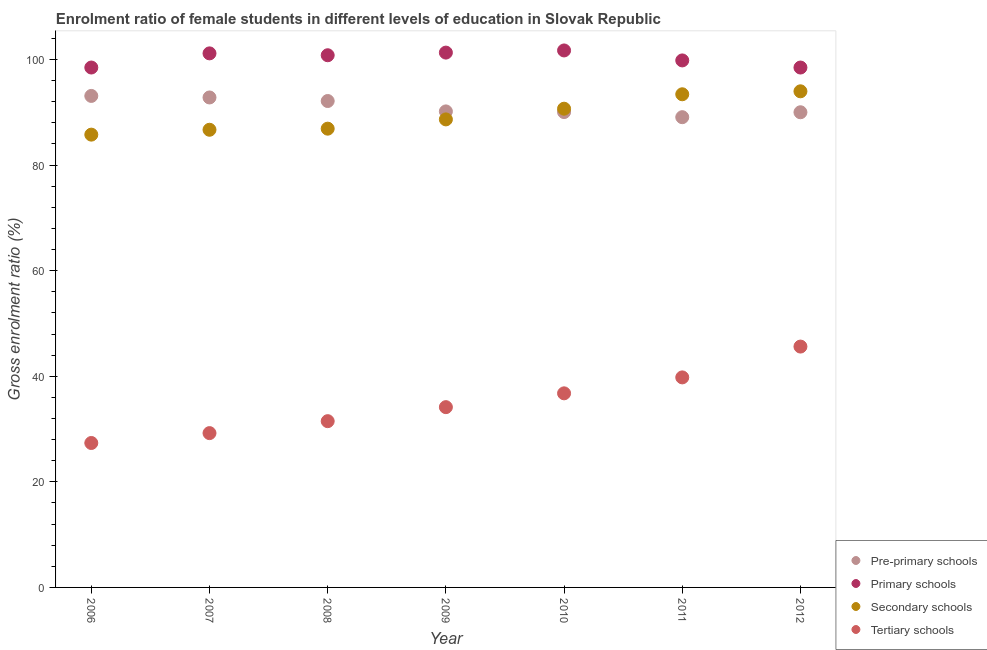How many different coloured dotlines are there?
Your response must be concise. 4. Is the number of dotlines equal to the number of legend labels?
Your answer should be compact. Yes. What is the gross enrolment ratio(male) in secondary schools in 2009?
Your answer should be compact. 88.65. Across all years, what is the maximum gross enrolment ratio(male) in secondary schools?
Ensure brevity in your answer.  93.97. Across all years, what is the minimum gross enrolment ratio(male) in tertiary schools?
Offer a terse response. 27.36. In which year was the gross enrolment ratio(male) in pre-primary schools maximum?
Make the answer very short. 2006. What is the total gross enrolment ratio(male) in pre-primary schools in the graph?
Provide a short and direct response. 637.28. What is the difference between the gross enrolment ratio(male) in pre-primary schools in 2007 and that in 2010?
Keep it short and to the point. 2.76. What is the difference between the gross enrolment ratio(male) in primary schools in 2006 and the gross enrolment ratio(male) in secondary schools in 2009?
Provide a succinct answer. 9.82. What is the average gross enrolment ratio(male) in tertiary schools per year?
Provide a succinct answer. 34.91. In the year 2009, what is the difference between the gross enrolment ratio(male) in secondary schools and gross enrolment ratio(male) in pre-primary schools?
Provide a succinct answer. -1.51. In how many years, is the gross enrolment ratio(male) in secondary schools greater than 4 %?
Ensure brevity in your answer.  7. What is the ratio of the gross enrolment ratio(male) in pre-primary schools in 2006 to that in 2008?
Provide a succinct answer. 1.01. What is the difference between the highest and the second highest gross enrolment ratio(male) in secondary schools?
Your answer should be very brief. 0.56. What is the difference between the highest and the lowest gross enrolment ratio(male) in pre-primary schools?
Keep it short and to the point. 4.03. In how many years, is the gross enrolment ratio(male) in primary schools greater than the average gross enrolment ratio(male) in primary schools taken over all years?
Provide a short and direct response. 4. Is the sum of the gross enrolment ratio(male) in secondary schools in 2006 and 2009 greater than the maximum gross enrolment ratio(male) in primary schools across all years?
Provide a succinct answer. Yes. Is it the case that in every year, the sum of the gross enrolment ratio(male) in tertiary schools and gross enrolment ratio(male) in pre-primary schools is greater than the sum of gross enrolment ratio(male) in secondary schools and gross enrolment ratio(male) in primary schools?
Ensure brevity in your answer.  No. Is it the case that in every year, the sum of the gross enrolment ratio(male) in pre-primary schools and gross enrolment ratio(male) in primary schools is greater than the gross enrolment ratio(male) in secondary schools?
Offer a terse response. Yes. Is the gross enrolment ratio(male) in pre-primary schools strictly greater than the gross enrolment ratio(male) in primary schools over the years?
Make the answer very short. No. Is the gross enrolment ratio(male) in tertiary schools strictly less than the gross enrolment ratio(male) in secondary schools over the years?
Make the answer very short. Yes. How many dotlines are there?
Keep it short and to the point. 4. How many years are there in the graph?
Offer a terse response. 7. What is the difference between two consecutive major ticks on the Y-axis?
Keep it short and to the point. 20. Are the values on the major ticks of Y-axis written in scientific E-notation?
Your answer should be compact. No. What is the title of the graph?
Keep it short and to the point. Enrolment ratio of female students in different levels of education in Slovak Republic. Does "Other Minerals" appear as one of the legend labels in the graph?
Your answer should be very brief. No. What is the label or title of the X-axis?
Your response must be concise. Year. What is the label or title of the Y-axis?
Offer a very short reply. Gross enrolment ratio (%). What is the Gross enrolment ratio (%) of Pre-primary schools in 2006?
Your answer should be very brief. 93.09. What is the Gross enrolment ratio (%) in Primary schools in 2006?
Give a very brief answer. 98.47. What is the Gross enrolment ratio (%) of Secondary schools in 2006?
Give a very brief answer. 85.76. What is the Gross enrolment ratio (%) in Tertiary schools in 2006?
Provide a succinct answer. 27.36. What is the Gross enrolment ratio (%) of Pre-primary schools in 2007?
Offer a very short reply. 92.8. What is the Gross enrolment ratio (%) in Primary schools in 2007?
Ensure brevity in your answer.  101.15. What is the Gross enrolment ratio (%) of Secondary schools in 2007?
Offer a very short reply. 86.68. What is the Gross enrolment ratio (%) of Tertiary schools in 2007?
Make the answer very short. 29.23. What is the Gross enrolment ratio (%) of Pre-primary schools in 2008?
Your response must be concise. 92.13. What is the Gross enrolment ratio (%) of Primary schools in 2008?
Give a very brief answer. 100.8. What is the Gross enrolment ratio (%) in Secondary schools in 2008?
Give a very brief answer. 86.89. What is the Gross enrolment ratio (%) in Tertiary schools in 2008?
Offer a very short reply. 31.49. What is the Gross enrolment ratio (%) of Pre-primary schools in 2009?
Provide a succinct answer. 90.16. What is the Gross enrolment ratio (%) of Primary schools in 2009?
Keep it short and to the point. 101.3. What is the Gross enrolment ratio (%) in Secondary schools in 2009?
Your response must be concise. 88.65. What is the Gross enrolment ratio (%) in Tertiary schools in 2009?
Ensure brevity in your answer.  34.15. What is the Gross enrolment ratio (%) of Pre-primary schools in 2010?
Offer a terse response. 90.04. What is the Gross enrolment ratio (%) in Primary schools in 2010?
Your response must be concise. 101.71. What is the Gross enrolment ratio (%) of Secondary schools in 2010?
Offer a very short reply. 90.67. What is the Gross enrolment ratio (%) of Tertiary schools in 2010?
Your answer should be very brief. 36.76. What is the Gross enrolment ratio (%) of Pre-primary schools in 2011?
Your answer should be very brief. 89.07. What is the Gross enrolment ratio (%) in Primary schools in 2011?
Your response must be concise. 99.82. What is the Gross enrolment ratio (%) in Secondary schools in 2011?
Ensure brevity in your answer.  93.41. What is the Gross enrolment ratio (%) of Tertiary schools in 2011?
Provide a succinct answer. 39.78. What is the Gross enrolment ratio (%) in Pre-primary schools in 2012?
Your answer should be very brief. 90. What is the Gross enrolment ratio (%) of Primary schools in 2012?
Offer a terse response. 98.47. What is the Gross enrolment ratio (%) of Secondary schools in 2012?
Offer a terse response. 93.97. What is the Gross enrolment ratio (%) in Tertiary schools in 2012?
Offer a very short reply. 45.62. Across all years, what is the maximum Gross enrolment ratio (%) in Pre-primary schools?
Your answer should be very brief. 93.09. Across all years, what is the maximum Gross enrolment ratio (%) in Primary schools?
Offer a terse response. 101.71. Across all years, what is the maximum Gross enrolment ratio (%) of Secondary schools?
Provide a short and direct response. 93.97. Across all years, what is the maximum Gross enrolment ratio (%) of Tertiary schools?
Provide a succinct answer. 45.62. Across all years, what is the minimum Gross enrolment ratio (%) of Pre-primary schools?
Offer a terse response. 89.07. Across all years, what is the minimum Gross enrolment ratio (%) in Primary schools?
Give a very brief answer. 98.47. Across all years, what is the minimum Gross enrolment ratio (%) in Secondary schools?
Your response must be concise. 85.76. Across all years, what is the minimum Gross enrolment ratio (%) in Tertiary schools?
Your answer should be compact. 27.36. What is the total Gross enrolment ratio (%) in Pre-primary schools in the graph?
Provide a succinct answer. 637.28. What is the total Gross enrolment ratio (%) in Primary schools in the graph?
Give a very brief answer. 701.71. What is the total Gross enrolment ratio (%) of Secondary schools in the graph?
Keep it short and to the point. 626.03. What is the total Gross enrolment ratio (%) of Tertiary schools in the graph?
Your response must be concise. 244.38. What is the difference between the Gross enrolment ratio (%) of Pre-primary schools in 2006 and that in 2007?
Keep it short and to the point. 0.29. What is the difference between the Gross enrolment ratio (%) in Primary schools in 2006 and that in 2007?
Keep it short and to the point. -2.68. What is the difference between the Gross enrolment ratio (%) of Secondary schools in 2006 and that in 2007?
Your answer should be very brief. -0.92. What is the difference between the Gross enrolment ratio (%) of Tertiary schools in 2006 and that in 2007?
Offer a very short reply. -1.87. What is the difference between the Gross enrolment ratio (%) of Pre-primary schools in 2006 and that in 2008?
Give a very brief answer. 0.96. What is the difference between the Gross enrolment ratio (%) in Primary schools in 2006 and that in 2008?
Your response must be concise. -2.33. What is the difference between the Gross enrolment ratio (%) of Secondary schools in 2006 and that in 2008?
Your answer should be very brief. -1.13. What is the difference between the Gross enrolment ratio (%) in Tertiary schools in 2006 and that in 2008?
Your answer should be very brief. -4.14. What is the difference between the Gross enrolment ratio (%) of Pre-primary schools in 2006 and that in 2009?
Offer a terse response. 2.93. What is the difference between the Gross enrolment ratio (%) of Primary schools in 2006 and that in 2009?
Make the answer very short. -2.83. What is the difference between the Gross enrolment ratio (%) in Secondary schools in 2006 and that in 2009?
Offer a terse response. -2.89. What is the difference between the Gross enrolment ratio (%) in Tertiary schools in 2006 and that in 2009?
Offer a very short reply. -6.79. What is the difference between the Gross enrolment ratio (%) of Pre-primary schools in 2006 and that in 2010?
Provide a short and direct response. 3.06. What is the difference between the Gross enrolment ratio (%) of Primary schools in 2006 and that in 2010?
Your answer should be compact. -3.23. What is the difference between the Gross enrolment ratio (%) of Secondary schools in 2006 and that in 2010?
Keep it short and to the point. -4.91. What is the difference between the Gross enrolment ratio (%) of Tertiary schools in 2006 and that in 2010?
Offer a very short reply. -9.41. What is the difference between the Gross enrolment ratio (%) of Pre-primary schools in 2006 and that in 2011?
Provide a short and direct response. 4.03. What is the difference between the Gross enrolment ratio (%) of Primary schools in 2006 and that in 2011?
Give a very brief answer. -1.35. What is the difference between the Gross enrolment ratio (%) of Secondary schools in 2006 and that in 2011?
Keep it short and to the point. -7.64. What is the difference between the Gross enrolment ratio (%) in Tertiary schools in 2006 and that in 2011?
Offer a very short reply. -12.43. What is the difference between the Gross enrolment ratio (%) of Pre-primary schools in 2006 and that in 2012?
Offer a terse response. 3.09. What is the difference between the Gross enrolment ratio (%) in Primary schools in 2006 and that in 2012?
Provide a short and direct response. 0. What is the difference between the Gross enrolment ratio (%) in Secondary schools in 2006 and that in 2012?
Offer a very short reply. -8.21. What is the difference between the Gross enrolment ratio (%) of Tertiary schools in 2006 and that in 2012?
Ensure brevity in your answer.  -18.26. What is the difference between the Gross enrolment ratio (%) of Pre-primary schools in 2007 and that in 2008?
Make the answer very short. 0.67. What is the difference between the Gross enrolment ratio (%) in Primary schools in 2007 and that in 2008?
Make the answer very short. 0.36. What is the difference between the Gross enrolment ratio (%) of Secondary schools in 2007 and that in 2008?
Ensure brevity in your answer.  -0.21. What is the difference between the Gross enrolment ratio (%) of Tertiary schools in 2007 and that in 2008?
Offer a terse response. -2.26. What is the difference between the Gross enrolment ratio (%) of Pre-primary schools in 2007 and that in 2009?
Keep it short and to the point. 2.64. What is the difference between the Gross enrolment ratio (%) in Primary schools in 2007 and that in 2009?
Offer a terse response. -0.15. What is the difference between the Gross enrolment ratio (%) in Secondary schools in 2007 and that in 2009?
Make the answer very short. -1.96. What is the difference between the Gross enrolment ratio (%) in Tertiary schools in 2007 and that in 2009?
Keep it short and to the point. -4.92. What is the difference between the Gross enrolment ratio (%) of Pre-primary schools in 2007 and that in 2010?
Give a very brief answer. 2.76. What is the difference between the Gross enrolment ratio (%) of Primary schools in 2007 and that in 2010?
Give a very brief answer. -0.55. What is the difference between the Gross enrolment ratio (%) in Secondary schools in 2007 and that in 2010?
Make the answer very short. -3.99. What is the difference between the Gross enrolment ratio (%) in Tertiary schools in 2007 and that in 2010?
Ensure brevity in your answer.  -7.53. What is the difference between the Gross enrolment ratio (%) of Pre-primary schools in 2007 and that in 2011?
Keep it short and to the point. 3.74. What is the difference between the Gross enrolment ratio (%) of Primary schools in 2007 and that in 2011?
Offer a very short reply. 1.34. What is the difference between the Gross enrolment ratio (%) in Secondary schools in 2007 and that in 2011?
Keep it short and to the point. -6.72. What is the difference between the Gross enrolment ratio (%) of Tertiary schools in 2007 and that in 2011?
Give a very brief answer. -10.55. What is the difference between the Gross enrolment ratio (%) in Pre-primary schools in 2007 and that in 2012?
Ensure brevity in your answer.  2.8. What is the difference between the Gross enrolment ratio (%) of Primary schools in 2007 and that in 2012?
Offer a very short reply. 2.68. What is the difference between the Gross enrolment ratio (%) of Secondary schools in 2007 and that in 2012?
Ensure brevity in your answer.  -7.28. What is the difference between the Gross enrolment ratio (%) of Tertiary schools in 2007 and that in 2012?
Keep it short and to the point. -16.39. What is the difference between the Gross enrolment ratio (%) in Pre-primary schools in 2008 and that in 2009?
Give a very brief answer. 1.97. What is the difference between the Gross enrolment ratio (%) in Primary schools in 2008 and that in 2009?
Your answer should be compact. -0.5. What is the difference between the Gross enrolment ratio (%) of Secondary schools in 2008 and that in 2009?
Offer a terse response. -1.76. What is the difference between the Gross enrolment ratio (%) in Tertiary schools in 2008 and that in 2009?
Provide a short and direct response. -2.65. What is the difference between the Gross enrolment ratio (%) in Pre-primary schools in 2008 and that in 2010?
Provide a succinct answer. 2.09. What is the difference between the Gross enrolment ratio (%) in Primary schools in 2008 and that in 2010?
Give a very brief answer. -0.91. What is the difference between the Gross enrolment ratio (%) of Secondary schools in 2008 and that in 2010?
Provide a short and direct response. -3.78. What is the difference between the Gross enrolment ratio (%) in Tertiary schools in 2008 and that in 2010?
Your answer should be very brief. -5.27. What is the difference between the Gross enrolment ratio (%) in Pre-primary schools in 2008 and that in 2011?
Keep it short and to the point. 3.06. What is the difference between the Gross enrolment ratio (%) of Primary schools in 2008 and that in 2011?
Your answer should be very brief. 0.98. What is the difference between the Gross enrolment ratio (%) of Secondary schools in 2008 and that in 2011?
Keep it short and to the point. -6.51. What is the difference between the Gross enrolment ratio (%) in Tertiary schools in 2008 and that in 2011?
Offer a very short reply. -8.29. What is the difference between the Gross enrolment ratio (%) in Pre-primary schools in 2008 and that in 2012?
Your answer should be very brief. 2.13. What is the difference between the Gross enrolment ratio (%) of Primary schools in 2008 and that in 2012?
Make the answer very short. 2.33. What is the difference between the Gross enrolment ratio (%) in Secondary schools in 2008 and that in 2012?
Ensure brevity in your answer.  -7.08. What is the difference between the Gross enrolment ratio (%) in Tertiary schools in 2008 and that in 2012?
Your answer should be compact. -14.13. What is the difference between the Gross enrolment ratio (%) of Pre-primary schools in 2009 and that in 2010?
Give a very brief answer. 0.12. What is the difference between the Gross enrolment ratio (%) in Primary schools in 2009 and that in 2010?
Offer a very short reply. -0.41. What is the difference between the Gross enrolment ratio (%) of Secondary schools in 2009 and that in 2010?
Your answer should be very brief. -2.03. What is the difference between the Gross enrolment ratio (%) in Tertiary schools in 2009 and that in 2010?
Your answer should be compact. -2.62. What is the difference between the Gross enrolment ratio (%) in Pre-primary schools in 2009 and that in 2011?
Give a very brief answer. 1.09. What is the difference between the Gross enrolment ratio (%) in Primary schools in 2009 and that in 2011?
Offer a very short reply. 1.48. What is the difference between the Gross enrolment ratio (%) of Secondary schools in 2009 and that in 2011?
Offer a terse response. -4.76. What is the difference between the Gross enrolment ratio (%) of Tertiary schools in 2009 and that in 2011?
Provide a succinct answer. -5.64. What is the difference between the Gross enrolment ratio (%) of Pre-primary schools in 2009 and that in 2012?
Ensure brevity in your answer.  0.16. What is the difference between the Gross enrolment ratio (%) in Primary schools in 2009 and that in 2012?
Your answer should be compact. 2.83. What is the difference between the Gross enrolment ratio (%) in Secondary schools in 2009 and that in 2012?
Make the answer very short. -5.32. What is the difference between the Gross enrolment ratio (%) in Tertiary schools in 2009 and that in 2012?
Your response must be concise. -11.47. What is the difference between the Gross enrolment ratio (%) of Pre-primary schools in 2010 and that in 2011?
Ensure brevity in your answer.  0.97. What is the difference between the Gross enrolment ratio (%) of Primary schools in 2010 and that in 2011?
Your response must be concise. 1.89. What is the difference between the Gross enrolment ratio (%) in Secondary schools in 2010 and that in 2011?
Keep it short and to the point. -2.73. What is the difference between the Gross enrolment ratio (%) in Tertiary schools in 2010 and that in 2011?
Give a very brief answer. -3.02. What is the difference between the Gross enrolment ratio (%) in Pre-primary schools in 2010 and that in 2012?
Give a very brief answer. 0.04. What is the difference between the Gross enrolment ratio (%) of Primary schools in 2010 and that in 2012?
Your answer should be very brief. 3.24. What is the difference between the Gross enrolment ratio (%) in Secondary schools in 2010 and that in 2012?
Make the answer very short. -3.29. What is the difference between the Gross enrolment ratio (%) of Tertiary schools in 2010 and that in 2012?
Your answer should be very brief. -8.86. What is the difference between the Gross enrolment ratio (%) of Pre-primary schools in 2011 and that in 2012?
Provide a short and direct response. -0.93. What is the difference between the Gross enrolment ratio (%) of Primary schools in 2011 and that in 2012?
Your answer should be compact. 1.35. What is the difference between the Gross enrolment ratio (%) of Secondary schools in 2011 and that in 2012?
Your answer should be very brief. -0.56. What is the difference between the Gross enrolment ratio (%) in Tertiary schools in 2011 and that in 2012?
Your answer should be compact. -5.84. What is the difference between the Gross enrolment ratio (%) in Pre-primary schools in 2006 and the Gross enrolment ratio (%) in Primary schools in 2007?
Give a very brief answer. -8.06. What is the difference between the Gross enrolment ratio (%) of Pre-primary schools in 2006 and the Gross enrolment ratio (%) of Secondary schools in 2007?
Ensure brevity in your answer.  6.41. What is the difference between the Gross enrolment ratio (%) in Pre-primary schools in 2006 and the Gross enrolment ratio (%) in Tertiary schools in 2007?
Provide a succinct answer. 63.86. What is the difference between the Gross enrolment ratio (%) in Primary schools in 2006 and the Gross enrolment ratio (%) in Secondary schools in 2007?
Provide a succinct answer. 11.79. What is the difference between the Gross enrolment ratio (%) of Primary schools in 2006 and the Gross enrolment ratio (%) of Tertiary schools in 2007?
Your response must be concise. 69.24. What is the difference between the Gross enrolment ratio (%) in Secondary schools in 2006 and the Gross enrolment ratio (%) in Tertiary schools in 2007?
Provide a succinct answer. 56.53. What is the difference between the Gross enrolment ratio (%) of Pre-primary schools in 2006 and the Gross enrolment ratio (%) of Primary schools in 2008?
Your answer should be compact. -7.71. What is the difference between the Gross enrolment ratio (%) of Pre-primary schools in 2006 and the Gross enrolment ratio (%) of Secondary schools in 2008?
Offer a terse response. 6.2. What is the difference between the Gross enrolment ratio (%) in Pre-primary schools in 2006 and the Gross enrolment ratio (%) in Tertiary schools in 2008?
Make the answer very short. 61.6. What is the difference between the Gross enrolment ratio (%) in Primary schools in 2006 and the Gross enrolment ratio (%) in Secondary schools in 2008?
Your answer should be very brief. 11.58. What is the difference between the Gross enrolment ratio (%) of Primary schools in 2006 and the Gross enrolment ratio (%) of Tertiary schools in 2008?
Provide a short and direct response. 66.98. What is the difference between the Gross enrolment ratio (%) of Secondary schools in 2006 and the Gross enrolment ratio (%) of Tertiary schools in 2008?
Your answer should be compact. 54.27. What is the difference between the Gross enrolment ratio (%) in Pre-primary schools in 2006 and the Gross enrolment ratio (%) in Primary schools in 2009?
Make the answer very short. -8.21. What is the difference between the Gross enrolment ratio (%) in Pre-primary schools in 2006 and the Gross enrolment ratio (%) in Secondary schools in 2009?
Offer a very short reply. 4.44. What is the difference between the Gross enrolment ratio (%) of Pre-primary schools in 2006 and the Gross enrolment ratio (%) of Tertiary schools in 2009?
Your response must be concise. 58.95. What is the difference between the Gross enrolment ratio (%) in Primary schools in 2006 and the Gross enrolment ratio (%) in Secondary schools in 2009?
Ensure brevity in your answer.  9.82. What is the difference between the Gross enrolment ratio (%) in Primary schools in 2006 and the Gross enrolment ratio (%) in Tertiary schools in 2009?
Your response must be concise. 64.33. What is the difference between the Gross enrolment ratio (%) in Secondary schools in 2006 and the Gross enrolment ratio (%) in Tertiary schools in 2009?
Your answer should be compact. 51.62. What is the difference between the Gross enrolment ratio (%) of Pre-primary schools in 2006 and the Gross enrolment ratio (%) of Primary schools in 2010?
Provide a short and direct response. -8.61. What is the difference between the Gross enrolment ratio (%) of Pre-primary schools in 2006 and the Gross enrolment ratio (%) of Secondary schools in 2010?
Your answer should be very brief. 2.42. What is the difference between the Gross enrolment ratio (%) of Pre-primary schools in 2006 and the Gross enrolment ratio (%) of Tertiary schools in 2010?
Provide a short and direct response. 56.33. What is the difference between the Gross enrolment ratio (%) in Primary schools in 2006 and the Gross enrolment ratio (%) in Secondary schools in 2010?
Offer a terse response. 7.8. What is the difference between the Gross enrolment ratio (%) in Primary schools in 2006 and the Gross enrolment ratio (%) in Tertiary schools in 2010?
Offer a very short reply. 61.71. What is the difference between the Gross enrolment ratio (%) in Secondary schools in 2006 and the Gross enrolment ratio (%) in Tertiary schools in 2010?
Your answer should be very brief. 49. What is the difference between the Gross enrolment ratio (%) in Pre-primary schools in 2006 and the Gross enrolment ratio (%) in Primary schools in 2011?
Your response must be concise. -6.73. What is the difference between the Gross enrolment ratio (%) in Pre-primary schools in 2006 and the Gross enrolment ratio (%) in Secondary schools in 2011?
Make the answer very short. -0.31. What is the difference between the Gross enrolment ratio (%) of Pre-primary schools in 2006 and the Gross enrolment ratio (%) of Tertiary schools in 2011?
Ensure brevity in your answer.  53.31. What is the difference between the Gross enrolment ratio (%) of Primary schools in 2006 and the Gross enrolment ratio (%) of Secondary schools in 2011?
Provide a succinct answer. 5.07. What is the difference between the Gross enrolment ratio (%) in Primary schools in 2006 and the Gross enrolment ratio (%) in Tertiary schools in 2011?
Ensure brevity in your answer.  58.69. What is the difference between the Gross enrolment ratio (%) in Secondary schools in 2006 and the Gross enrolment ratio (%) in Tertiary schools in 2011?
Ensure brevity in your answer.  45.98. What is the difference between the Gross enrolment ratio (%) in Pre-primary schools in 2006 and the Gross enrolment ratio (%) in Primary schools in 2012?
Keep it short and to the point. -5.38. What is the difference between the Gross enrolment ratio (%) of Pre-primary schools in 2006 and the Gross enrolment ratio (%) of Secondary schools in 2012?
Provide a short and direct response. -0.88. What is the difference between the Gross enrolment ratio (%) in Pre-primary schools in 2006 and the Gross enrolment ratio (%) in Tertiary schools in 2012?
Make the answer very short. 47.47. What is the difference between the Gross enrolment ratio (%) in Primary schools in 2006 and the Gross enrolment ratio (%) in Secondary schools in 2012?
Ensure brevity in your answer.  4.5. What is the difference between the Gross enrolment ratio (%) in Primary schools in 2006 and the Gross enrolment ratio (%) in Tertiary schools in 2012?
Give a very brief answer. 52.85. What is the difference between the Gross enrolment ratio (%) in Secondary schools in 2006 and the Gross enrolment ratio (%) in Tertiary schools in 2012?
Provide a short and direct response. 40.14. What is the difference between the Gross enrolment ratio (%) of Pre-primary schools in 2007 and the Gross enrolment ratio (%) of Primary schools in 2008?
Offer a very short reply. -8. What is the difference between the Gross enrolment ratio (%) in Pre-primary schools in 2007 and the Gross enrolment ratio (%) in Secondary schools in 2008?
Give a very brief answer. 5.91. What is the difference between the Gross enrolment ratio (%) in Pre-primary schools in 2007 and the Gross enrolment ratio (%) in Tertiary schools in 2008?
Make the answer very short. 61.31. What is the difference between the Gross enrolment ratio (%) in Primary schools in 2007 and the Gross enrolment ratio (%) in Secondary schools in 2008?
Ensure brevity in your answer.  14.26. What is the difference between the Gross enrolment ratio (%) in Primary schools in 2007 and the Gross enrolment ratio (%) in Tertiary schools in 2008?
Keep it short and to the point. 69.66. What is the difference between the Gross enrolment ratio (%) in Secondary schools in 2007 and the Gross enrolment ratio (%) in Tertiary schools in 2008?
Your response must be concise. 55.19. What is the difference between the Gross enrolment ratio (%) of Pre-primary schools in 2007 and the Gross enrolment ratio (%) of Primary schools in 2009?
Give a very brief answer. -8.5. What is the difference between the Gross enrolment ratio (%) of Pre-primary schools in 2007 and the Gross enrolment ratio (%) of Secondary schools in 2009?
Make the answer very short. 4.15. What is the difference between the Gross enrolment ratio (%) of Pre-primary schools in 2007 and the Gross enrolment ratio (%) of Tertiary schools in 2009?
Provide a short and direct response. 58.66. What is the difference between the Gross enrolment ratio (%) in Primary schools in 2007 and the Gross enrolment ratio (%) in Secondary schools in 2009?
Provide a succinct answer. 12.51. What is the difference between the Gross enrolment ratio (%) in Primary schools in 2007 and the Gross enrolment ratio (%) in Tertiary schools in 2009?
Your answer should be very brief. 67.01. What is the difference between the Gross enrolment ratio (%) in Secondary schools in 2007 and the Gross enrolment ratio (%) in Tertiary schools in 2009?
Give a very brief answer. 52.54. What is the difference between the Gross enrolment ratio (%) in Pre-primary schools in 2007 and the Gross enrolment ratio (%) in Primary schools in 2010?
Provide a short and direct response. -8.9. What is the difference between the Gross enrolment ratio (%) of Pre-primary schools in 2007 and the Gross enrolment ratio (%) of Secondary schools in 2010?
Make the answer very short. 2.13. What is the difference between the Gross enrolment ratio (%) of Pre-primary schools in 2007 and the Gross enrolment ratio (%) of Tertiary schools in 2010?
Ensure brevity in your answer.  56.04. What is the difference between the Gross enrolment ratio (%) of Primary schools in 2007 and the Gross enrolment ratio (%) of Secondary schools in 2010?
Offer a terse response. 10.48. What is the difference between the Gross enrolment ratio (%) in Primary schools in 2007 and the Gross enrolment ratio (%) in Tertiary schools in 2010?
Your answer should be compact. 64.39. What is the difference between the Gross enrolment ratio (%) in Secondary schools in 2007 and the Gross enrolment ratio (%) in Tertiary schools in 2010?
Make the answer very short. 49.92. What is the difference between the Gross enrolment ratio (%) of Pre-primary schools in 2007 and the Gross enrolment ratio (%) of Primary schools in 2011?
Your answer should be very brief. -7.02. What is the difference between the Gross enrolment ratio (%) of Pre-primary schools in 2007 and the Gross enrolment ratio (%) of Secondary schools in 2011?
Your answer should be compact. -0.6. What is the difference between the Gross enrolment ratio (%) of Pre-primary schools in 2007 and the Gross enrolment ratio (%) of Tertiary schools in 2011?
Make the answer very short. 53.02. What is the difference between the Gross enrolment ratio (%) in Primary schools in 2007 and the Gross enrolment ratio (%) in Secondary schools in 2011?
Your answer should be compact. 7.75. What is the difference between the Gross enrolment ratio (%) in Primary schools in 2007 and the Gross enrolment ratio (%) in Tertiary schools in 2011?
Provide a short and direct response. 61.37. What is the difference between the Gross enrolment ratio (%) of Secondary schools in 2007 and the Gross enrolment ratio (%) of Tertiary schools in 2011?
Make the answer very short. 46.9. What is the difference between the Gross enrolment ratio (%) of Pre-primary schools in 2007 and the Gross enrolment ratio (%) of Primary schools in 2012?
Your response must be concise. -5.67. What is the difference between the Gross enrolment ratio (%) in Pre-primary schools in 2007 and the Gross enrolment ratio (%) in Secondary schools in 2012?
Your answer should be compact. -1.17. What is the difference between the Gross enrolment ratio (%) of Pre-primary schools in 2007 and the Gross enrolment ratio (%) of Tertiary schools in 2012?
Provide a short and direct response. 47.18. What is the difference between the Gross enrolment ratio (%) in Primary schools in 2007 and the Gross enrolment ratio (%) in Secondary schools in 2012?
Provide a succinct answer. 7.19. What is the difference between the Gross enrolment ratio (%) in Primary schools in 2007 and the Gross enrolment ratio (%) in Tertiary schools in 2012?
Your response must be concise. 55.53. What is the difference between the Gross enrolment ratio (%) in Secondary schools in 2007 and the Gross enrolment ratio (%) in Tertiary schools in 2012?
Offer a terse response. 41.06. What is the difference between the Gross enrolment ratio (%) of Pre-primary schools in 2008 and the Gross enrolment ratio (%) of Primary schools in 2009?
Make the answer very short. -9.17. What is the difference between the Gross enrolment ratio (%) of Pre-primary schools in 2008 and the Gross enrolment ratio (%) of Secondary schools in 2009?
Your answer should be compact. 3.48. What is the difference between the Gross enrolment ratio (%) in Pre-primary schools in 2008 and the Gross enrolment ratio (%) in Tertiary schools in 2009?
Offer a terse response. 57.98. What is the difference between the Gross enrolment ratio (%) of Primary schools in 2008 and the Gross enrolment ratio (%) of Secondary schools in 2009?
Provide a short and direct response. 12.15. What is the difference between the Gross enrolment ratio (%) of Primary schools in 2008 and the Gross enrolment ratio (%) of Tertiary schools in 2009?
Give a very brief answer. 66.65. What is the difference between the Gross enrolment ratio (%) of Secondary schools in 2008 and the Gross enrolment ratio (%) of Tertiary schools in 2009?
Your answer should be compact. 52.74. What is the difference between the Gross enrolment ratio (%) of Pre-primary schools in 2008 and the Gross enrolment ratio (%) of Primary schools in 2010?
Your answer should be compact. -9.58. What is the difference between the Gross enrolment ratio (%) of Pre-primary schools in 2008 and the Gross enrolment ratio (%) of Secondary schools in 2010?
Provide a short and direct response. 1.45. What is the difference between the Gross enrolment ratio (%) in Pre-primary schools in 2008 and the Gross enrolment ratio (%) in Tertiary schools in 2010?
Ensure brevity in your answer.  55.37. What is the difference between the Gross enrolment ratio (%) in Primary schools in 2008 and the Gross enrolment ratio (%) in Secondary schools in 2010?
Make the answer very short. 10.12. What is the difference between the Gross enrolment ratio (%) in Primary schools in 2008 and the Gross enrolment ratio (%) in Tertiary schools in 2010?
Your answer should be compact. 64.04. What is the difference between the Gross enrolment ratio (%) in Secondary schools in 2008 and the Gross enrolment ratio (%) in Tertiary schools in 2010?
Keep it short and to the point. 50.13. What is the difference between the Gross enrolment ratio (%) of Pre-primary schools in 2008 and the Gross enrolment ratio (%) of Primary schools in 2011?
Provide a succinct answer. -7.69. What is the difference between the Gross enrolment ratio (%) in Pre-primary schools in 2008 and the Gross enrolment ratio (%) in Secondary schools in 2011?
Keep it short and to the point. -1.28. What is the difference between the Gross enrolment ratio (%) in Pre-primary schools in 2008 and the Gross enrolment ratio (%) in Tertiary schools in 2011?
Your response must be concise. 52.35. What is the difference between the Gross enrolment ratio (%) in Primary schools in 2008 and the Gross enrolment ratio (%) in Secondary schools in 2011?
Keep it short and to the point. 7.39. What is the difference between the Gross enrolment ratio (%) in Primary schools in 2008 and the Gross enrolment ratio (%) in Tertiary schools in 2011?
Your answer should be very brief. 61.02. What is the difference between the Gross enrolment ratio (%) in Secondary schools in 2008 and the Gross enrolment ratio (%) in Tertiary schools in 2011?
Your answer should be compact. 47.11. What is the difference between the Gross enrolment ratio (%) of Pre-primary schools in 2008 and the Gross enrolment ratio (%) of Primary schools in 2012?
Make the answer very short. -6.34. What is the difference between the Gross enrolment ratio (%) in Pre-primary schools in 2008 and the Gross enrolment ratio (%) in Secondary schools in 2012?
Ensure brevity in your answer.  -1.84. What is the difference between the Gross enrolment ratio (%) of Pre-primary schools in 2008 and the Gross enrolment ratio (%) of Tertiary schools in 2012?
Offer a very short reply. 46.51. What is the difference between the Gross enrolment ratio (%) of Primary schools in 2008 and the Gross enrolment ratio (%) of Secondary schools in 2012?
Give a very brief answer. 6.83. What is the difference between the Gross enrolment ratio (%) in Primary schools in 2008 and the Gross enrolment ratio (%) in Tertiary schools in 2012?
Provide a short and direct response. 55.18. What is the difference between the Gross enrolment ratio (%) in Secondary schools in 2008 and the Gross enrolment ratio (%) in Tertiary schools in 2012?
Ensure brevity in your answer.  41.27. What is the difference between the Gross enrolment ratio (%) in Pre-primary schools in 2009 and the Gross enrolment ratio (%) in Primary schools in 2010?
Provide a short and direct response. -11.54. What is the difference between the Gross enrolment ratio (%) in Pre-primary schools in 2009 and the Gross enrolment ratio (%) in Secondary schools in 2010?
Make the answer very short. -0.51. What is the difference between the Gross enrolment ratio (%) of Pre-primary schools in 2009 and the Gross enrolment ratio (%) of Tertiary schools in 2010?
Your response must be concise. 53.4. What is the difference between the Gross enrolment ratio (%) of Primary schools in 2009 and the Gross enrolment ratio (%) of Secondary schools in 2010?
Give a very brief answer. 10.62. What is the difference between the Gross enrolment ratio (%) of Primary schools in 2009 and the Gross enrolment ratio (%) of Tertiary schools in 2010?
Your answer should be compact. 64.54. What is the difference between the Gross enrolment ratio (%) in Secondary schools in 2009 and the Gross enrolment ratio (%) in Tertiary schools in 2010?
Provide a short and direct response. 51.89. What is the difference between the Gross enrolment ratio (%) of Pre-primary schools in 2009 and the Gross enrolment ratio (%) of Primary schools in 2011?
Offer a very short reply. -9.66. What is the difference between the Gross enrolment ratio (%) of Pre-primary schools in 2009 and the Gross enrolment ratio (%) of Secondary schools in 2011?
Provide a short and direct response. -3.25. What is the difference between the Gross enrolment ratio (%) of Pre-primary schools in 2009 and the Gross enrolment ratio (%) of Tertiary schools in 2011?
Offer a terse response. 50.38. What is the difference between the Gross enrolment ratio (%) in Primary schools in 2009 and the Gross enrolment ratio (%) in Secondary schools in 2011?
Offer a terse response. 7.89. What is the difference between the Gross enrolment ratio (%) in Primary schools in 2009 and the Gross enrolment ratio (%) in Tertiary schools in 2011?
Offer a very short reply. 61.52. What is the difference between the Gross enrolment ratio (%) of Secondary schools in 2009 and the Gross enrolment ratio (%) of Tertiary schools in 2011?
Your answer should be very brief. 48.87. What is the difference between the Gross enrolment ratio (%) of Pre-primary schools in 2009 and the Gross enrolment ratio (%) of Primary schools in 2012?
Your answer should be very brief. -8.31. What is the difference between the Gross enrolment ratio (%) of Pre-primary schools in 2009 and the Gross enrolment ratio (%) of Secondary schools in 2012?
Offer a terse response. -3.81. What is the difference between the Gross enrolment ratio (%) in Pre-primary schools in 2009 and the Gross enrolment ratio (%) in Tertiary schools in 2012?
Your answer should be compact. 44.54. What is the difference between the Gross enrolment ratio (%) of Primary schools in 2009 and the Gross enrolment ratio (%) of Secondary schools in 2012?
Make the answer very short. 7.33. What is the difference between the Gross enrolment ratio (%) in Primary schools in 2009 and the Gross enrolment ratio (%) in Tertiary schools in 2012?
Provide a succinct answer. 55.68. What is the difference between the Gross enrolment ratio (%) in Secondary schools in 2009 and the Gross enrolment ratio (%) in Tertiary schools in 2012?
Make the answer very short. 43.03. What is the difference between the Gross enrolment ratio (%) in Pre-primary schools in 2010 and the Gross enrolment ratio (%) in Primary schools in 2011?
Ensure brevity in your answer.  -9.78. What is the difference between the Gross enrolment ratio (%) of Pre-primary schools in 2010 and the Gross enrolment ratio (%) of Secondary schools in 2011?
Keep it short and to the point. -3.37. What is the difference between the Gross enrolment ratio (%) of Pre-primary schools in 2010 and the Gross enrolment ratio (%) of Tertiary schools in 2011?
Ensure brevity in your answer.  50.25. What is the difference between the Gross enrolment ratio (%) of Primary schools in 2010 and the Gross enrolment ratio (%) of Secondary schools in 2011?
Ensure brevity in your answer.  8.3. What is the difference between the Gross enrolment ratio (%) of Primary schools in 2010 and the Gross enrolment ratio (%) of Tertiary schools in 2011?
Offer a very short reply. 61.92. What is the difference between the Gross enrolment ratio (%) of Secondary schools in 2010 and the Gross enrolment ratio (%) of Tertiary schools in 2011?
Ensure brevity in your answer.  50.89. What is the difference between the Gross enrolment ratio (%) in Pre-primary schools in 2010 and the Gross enrolment ratio (%) in Primary schools in 2012?
Make the answer very short. -8.43. What is the difference between the Gross enrolment ratio (%) in Pre-primary schools in 2010 and the Gross enrolment ratio (%) in Secondary schools in 2012?
Offer a very short reply. -3.93. What is the difference between the Gross enrolment ratio (%) of Pre-primary schools in 2010 and the Gross enrolment ratio (%) of Tertiary schools in 2012?
Ensure brevity in your answer.  44.42. What is the difference between the Gross enrolment ratio (%) of Primary schools in 2010 and the Gross enrolment ratio (%) of Secondary schools in 2012?
Your answer should be compact. 7.74. What is the difference between the Gross enrolment ratio (%) in Primary schools in 2010 and the Gross enrolment ratio (%) in Tertiary schools in 2012?
Offer a terse response. 56.09. What is the difference between the Gross enrolment ratio (%) of Secondary schools in 2010 and the Gross enrolment ratio (%) of Tertiary schools in 2012?
Offer a very short reply. 45.06. What is the difference between the Gross enrolment ratio (%) of Pre-primary schools in 2011 and the Gross enrolment ratio (%) of Primary schools in 2012?
Your answer should be compact. -9.4. What is the difference between the Gross enrolment ratio (%) in Pre-primary schools in 2011 and the Gross enrolment ratio (%) in Secondary schools in 2012?
Ensure brevity in your answer.  -4.9. What is the difference between the Gross enrolment ratio (%) in Pre-primary schools in 2011 and the Gross enrolment ratio (%) in Tertiary schools in 2012?
Give a very brief answer. 43.45. What is the difference between the Gross enrolment ratio (%) of Primary schools in 2011 and the Gross enrolment ratio (%) of Secondary schools in 2012?
Give a very brief answer. 5.85. What is the difference between the Gross enrolment ratio (%) of Primary schools in 2011 and the Gross enrolment ratio (%) of Tertiary schools in 2012?
Give a very brief answer. 54.2. What is the difference between the Gross enrolment ratio (%) of Secondary schools in 2011 and the Gross enrolment ratio (%) of Tertiary schools in 2012?
Make the answer very short. 47.79. What is the average Gross enrolment ratio (%) of Pre-primary schools per year?
Ensure brevity in your answer.  91.04. What is the average Gross enrolment ratio (%) of Primary schools per year?
Offer a terse response. 100.24. What is the average Gross enrolment ratio (%) of Secondary schools per year?
Provide a succinct answer. 89.43. What is the average Gross enrolment ratio (%) in Tertiary schools per year?
Keep it short and to the point. 34.91. In the year 2006, what is the difference between the Gross enrolment ratio (%) of Pre-primary schools and Gross enrolment ratio (%) of Primary schools?
Your response must be concise. -5.38. In the year 2006, what is the difference between the Gross enrolment ratio (%) in Pre-primary schools and Gross enrolment ratio (%) in Secondary schools?
Offer a terse response. 7.33. In the year 2006, what is the difference between the Gross enrolment ratio (%) in Pre-primary schools and Gross enrolment ratio (%) in Tertiary schools?
Your answer should be compact. 65.74. In the year 2006, what is the difference between the Gross enrolment ratio (%) of Primary schools and Gross enrolment ratio (%) of Secondary schools?
Offer a very short reply. 12.71. In the year 2006, what is the difference between the Gross enrolment ratio (%) of Primary schools and Gross enrolment ratio (%) of Tertiary schools?
Provide a succinct answer. 71.12. In the year 2006, what is the difference between the Gross enrolment ratio (%) of Secondary schools and Gross enrolment ratio (%) of Tertiary schools?
Your answer should be very brief. 58.41. In the year 2007, what is the difference between the Gross enrolment ratio (%) in Pre-primary schools and Gross enrolment ratio (%) in Primary schools?
Give a very brief answer. -8.35. In the year 2007, what is the difference between the Gross enrolment ratio (%) in Pre-primary schools and Gross enrolment ratio (%) in Secondary schools?
Your response must be concise. 6.12. In the year 2007, what is the difference between the Gross enrolment ratio (%) of Pre-primary schools and Gross enrolment ratio (%) of Tertiary schools?
Your answer should be compact. 63.57. In the year 2007, what is the difference between the Gross enrolment ratio (%) in Primary schools and Gross enrolment ratio (%) in Secondary schools?
Your answer should be very brief. 14.47. In the year 2007, what is the difference between the Gross enrolment ratio (%) of Primary schools and Gross enrolment ratio (%) of Tertiary schools?
Offer a terse response. 71.93. In the year 2007, what is the difference between the Gross enrolment ratio (%) of Secondary schools and Gross enrolment ratio (%) of Tertiary schools?
Provide a succinct answer. 57.46. In the year 2008, what is the difference between the Gross enrolment ratio (%) in Pre-primary schools and Gross enrolment ratio (%) in Primary schools?
Ensure brevity in your answer.  -8.67. In the year 2008, what is the difference between the Gross enrolment ratio (%) of Pre-primary schools and Gross enrolment ratio (%) of Secondary schools?
Your response must be concise. 5.24. In the year 2008, what is the difference between the Gross enrolment ratio (%) in Pre-primary schools and Gross enrolment ratio (%) in Tertiary schools?
Keep it short and to the point. 60.64. In the year 2008, what is the difference between the Gross enrolment ratio (%) of Primary schools and Gross enrolment ratio (%) of Secondary schools?
Offer a terse response. 13.91. In the year 2008, what is the difference between the Gross enrolment ratio (%) of Primary schools and Gross enrolment ratio (%) of Tertiary schools?
Your answer should be compact. 69.31. In the year 2008, what is the difference between the Gross enrolment ratio (%) of Secondary schools and Gross enrolment ratio (%) of Tertiary schools?
Your answer should be compact. 55.4. In the year 2009, what is the difference between the Gross enrolment ratio (%) in Pre-primary schools and Gross enrolment ratio (%) in Primary schools?
Offer a very short reply. -11.14. In the year 2009, what is the difference between the Gross enrolment ratio (%) in Pre-primary schools and Gross enrolment ratio (%) in Secondary schools?
Ensure brevity in your answer.  1.51. In the year 2009, what is the difference between the Gross enrolment ratio (%) in Pre-primary schools and Gross enrolment ratio (%) in Tertiary schools?
Ensure brevity in your answer.  56.01. In the year 2009, what is the difference between the Gross enrolment ratio (%) in Primary schools and Gross enrolment ratio (%) in Secondary schools?
Your response must be concise. 12.65. In the year 2009, what is the difference between the Gross enrolment ratio (%) of Primary schools and Gross enrolment ratio (%) of Tertiary schools?
Offer a terse response. 67.15. In the year 2009, what is the difference between the Gross enrolment ratio (%) of Secondary schools and Gross enrolment ratio (%) of Tertiary schools?
Offer a terse response. 54.5. In the year 2010, what is the difference between the Gross enrolment ratio (%) in Pre-primary schools and Gross enrolment ratio (%) in Primary schools?
Make the answer very short. -11.67. In the year 2010, what is the difference between the Gross enrolment ratio (%) in Pre-primary schools and Gross enrolment ratio (%) in Secondary schools?
Offer a terse response. -0.64. In the year 2010, what is the difference between the Gross enrolment ratio (%) in Pre-primary schools and Gross enrolment ratio (%) in Tertiary schools?
Your answer should be compact. 53.27. In the year 2010, what is the difference between the Gross enrolment ratio (%) in Primary schools and Gross enrolment ratio (%) in Secondary schools?
Make the answer very short. 11.03. In the year 2010, what is the difference between the Gross enrolment ratio (%) in Primary schools and Gross enrolment ratio (%) in Tertiary schools?
Your answer should be very brief. 64.94. In the year 2010, what is the difference between the Gross enrolment ratio (%) in Secondary schools and Gross enrolment ratio (%) in Tertiary schools?
Your answer should be very brief. 53.91. In the year 2011, what is the difference between the Gross enrolment ratio (%) of Pre-primary schools and Gross enrolment ratio (%) of Primary schools?
Provide a short and direct response. -10.75. In the year 2011, what is the difference between the Gross enrolment ratio (%) in Pre-primary schools and Gross enrolment ratio (%) in Secondary schools?
Your answer should be compact. -4.34. In the year 2011, what is the difference between the Gross enrolment ratio (%) of Pre-primary schools and Gross enrolment ratio (%) of Tertiary schools?
Your answer should be very brief. 49.28. In the year 2011, what is the difference between the Gross enrolment ratio (%) of Primary schools and Gross enrolment ratio (%) of Secondary schools?
Provide a short and direct response. 6.41. In the year 2011, what is the difference between the Gross enrolment ratio (%) in Primary schools and Gross enrolment ratio (%) in Tertiary schools?
Offer a very short reply. 60.04. In the year 2011, what is the difference between the Gross enrolment ratio (%) in Secondary schools and Gross enrolment ratio (%) in Tertiary schools?
Your response must be concise. 53.62. In the year 2012, what is the difference between the Gross enrolment ratio (%) in Pre-primary schools and Gross enrolment ratio (%) in Primary schools?
Provide a succinct answer. -8.47. In the year 2012, what is the difference between the Gross enrolment ratio (%) in Pre-primary schools and Gross enrolment ratio (%) in Secondary schools?
Offer a very short reply. -3.97. In the year 2012, what is the difference between the Gross enrolment ratio (%) of Pre-primary schools and Gross enrolment ratio (%) of Tertiary schools?
Keep it short and to the point. 44.38. In the year 2012, what is the difference between the Gross enrolment ratio (%) of Primary schools and Gross enrolment ratio (%) of Secondary schools?
Offer a very short reply. 4.5. In the year 2012, what is the difference between the Gross enrolment ratio (%) of Primary schools and Gross enrolment ratio (%) of Tertiary schools?
Keep it short and to the point. 52.85. In the year 2012, what is the difference between the Gross enrolment ratio (%) in Secondary schools and Gross enrolment ratio (%) in Tertiary schools?
Ensure brevity in your answer.  48.35. What is the ratio of the Gross enrolment ratio (%) of Primary schools in 2006 to that in 2007?
Give a very brief answer. 0.97. What is the ratio of the Gross enrolment ratio (%) in Secondary schools in 2006 to that in 2007?
Provide a succinct answer. 0.99. What is the ratio of the Gross enrolment ratio (%) of Tertiary schools in 2006 to that in 2007?
Offer a very short reply. 0.94. What is the ratio of the Gross enrolment ratio (%) of Pre-primary schools in 2006 to that in 2008?
Make the answer very short. 1.01. What is the ratio of the Gross enrolment ratio (%) of Primary schools in 2006 to that in 2008?
Ensure brevity in your answer.  0.98. What is the ratio of the Gross enrolment ratio (%) in Tertiary schools in 2006 to that in 2008?
Provide a short and direct response. 0.87. What is the ratio of the Gross enrolment ratio (%) in Pre-primary schools in 2006 to that in 2009?
Provide a succinct answer. 1.03. What is the ratio of the Gross enrolment ratio (%) in Primary schools in 2006 to that in 2009?
Offer a terse response. 0.97. What is the ratio of the Gross enrolment ratio (%) in Secondary schools in 2006 to that in 2009?
Your answer should be compact. 0.97. What is the ratio of the Gross enrolment ratio (%) of Tertiary schools in 2006 to that in 2009?
Your answer should be compact. 0.8. What is the ratio of the Gross enrolment ratio (%) of Pre-primary schools in 2006 to that in 2010?
Your answer should be compact. 1.03. What is the ratio of the Gross enrolment ratio (%) of Primary schools in 2006 to that in 2010?
Make the answer very short. 0.97. What is the ratio of the Gross enrolment ratio (%) of Secondary schools in 2006 to that in 2010?
Offer a terse response. 0.95. What is the ratio of the Gross enrolment ratio (%) of Tertiary schools in 2006 to that in 2010?
Your answer should be compact. 0.74. What is the ratio of the Gross enrolment ratio (%) of Pre-primary schools in 2006 to that in 2011?
Offer a terse response. 1.05. What is the ratio of the Gross enrolment ratio (%) in Primary schools in 2006 to that in 2011?
Provide a succinct answer. 0.99. What is the ratio of the Gross enrolment ratio (%) of Secondary schools in 2006 to that in 2011?
Offer a terse response. 0.92. What is the ratio of the Gross enrolment ratio (%) of Tertiary schools in 2006 to that in 2011?
Make the answer very short. 0.69. What is the ratio of the Gross enrolment ratio (%) in Pre-primary schools in 2006 to that in 2012?
Give a very brief answer. 1.03. What is the ratio of the Gross enrolment ratio (%) of Primary schools in 2006 to that in 2012?
Your response must be concise. 1. What is the ratio of the Gross enrolment ratio (%) of Secondary schools in 2006 to that in 2012?
Offer a very short reply. 0.91. What is the ratio of the Gross enrolment ratio (%) of Tertiary schools in 2006 to that in 2012?
Your answer should be very brief. 0.6. What is the ratio of the Gross enrolment ratio (%) in Pre-primary schools in 2007 to that in 2008?
Ensure brevity in your answer.  1.01. What is the ratio of the Gross enrolment ratio (%) of Tertiary schools in 2007 to that in 2008?
Your answer should be compact. 0.93. What is the ratio of the Gross enrolment ratio (%) of Pre-primary schools in 2007 to that in 2009?
Offer a very short reply. 1.03. What is the ratio of the Gross enrolment ratio (%) in Secondary schools in 2007 to that in 2009?
Provide a short and direct response. 0.98. What is the ratio of the Gross enrolment ratio (%) of Tertiary schools in 2007 to that in 2009?
Keep it short and to the point. 0.86. What is the ratio of the Gross enrolment ratio (%) of Pre-primary schools in 2007 to that in 2010?
Offer a very short reply. 1.03. What is the ratio of the Gross enrolment ratio (%) in Primary schools in 2007 to that in 2010?
Your answer should be very brief. 0.99. What is the ratio of the Gross enrolment ratio (%) in Secondary schools in 2007 to that in 2010?
Offer a very short reply. 0.96. What is the ratio of the Gross enrolment ratio (%) in Tertiary schools in 2007 to that in 2010?
Make the answer very short. 0.8. What is the ratio of the Gross enrolment ratio (%) in Pre-primary schools in 2007 to that in 2011?
Offer a terse response. 1.04. What is the ratio of the Gross enrolment ratio (%) of Primary schools in 2007 to that in 2011?
Keep it short and to the point. 1.01. What is the ratio of the Gross enrolment ratio (%) of Secondary schools in 2007 to that in 2011?
Provide a succinct answer. 0.93. What is the ratio of the Gross enrolment ratio (%) in Tertiary schools in 2007 to that in 2011?
Your answer should be very brief. 0.73. What is the ratio of the Gross enrolment ratio (%) of Pre-primary schools in 2007 to that in 2012?
Your answer should be very brief. 1.03. What is the ratio of the Gross enrolment ratio (%) of Primary schools in 2007 to that in 2012?
Give a very brief answer. 1.03. What is the ratio of the Gross enrolment ratio (%) in Secondary schools in 2007 to that in 2012?
Your response must be concise. 0.92. What is the ratio of the Gross enrolment ratio (%) of Tertiary schools in 2007 to that in 2012?
Your response must be concise. 0.64. What is the ratio of the Gross enrolment ratio (%) of Pre-primary schools in 2008 to that in 2009?
Provide a short and direct response. 1.02. What is the ratio of the Gross enrolment ratio (%) of Primary schools in 2008 to that in 2009?
Provide a succinct answer. 1. What is the ratio of the Gross enrolment ratio (%) in Secondary schools in 2008 to that in 2009?
Ensure brevity in your answer.  0.98. What is the ratio of the Gross enrolment ratio (%) of Tertiary schools in 2008 to that in 2009?
Provide a short and direct response. 0.92. What is the ratio of the Gross enrolment ratio (%) in Pre-primary schools in 2008 to that in 2010?
Give a very brief answer. 1.02. What is the ratio of the Gross enrolment ratio (%) of Tertiary schools in 2008 to that in 2010?
Your answer should be very brief. 0.86. What is the ratio of the Gross enrolment ratio (%) of Pre-primary schools in 2008 to that in 2011?
Make the answer very short. 1.03. What is the ratio of the Gross enrolment ratio (%) in Primary schools in 2008 to that in 2011?
Provide a succinct answer. 1.01. What is the ratio of the Gross enrolment ratio (%) in Secondary schools in 2008 to that in 2011?
Ensure brevity in your answer.  0.93. What is the ratio of the Gross enrolment ratio (%) of Tertiary schools in 2008 to that in 2011?
Keep it short and to the point. 0.79. What is the ratio of the Gross enrolment ratio (%) in Pre-primary schools in 2008 to that in 2012?
Make the answer very short. 1.02. What is the ratio of the Gross enrolment ratio (%) of Primary schools in 2008 to that in 2012?
Your answer should be compact. 1.02. What is the ratio of the Gross enrolment ratio (%) of Secondary schools in 2008 to that in 2012?
Offer a terse response. 0.92. What is the ratio of the Gross enrolment ratio (%) in Tertiary schools in 2008 to that in 2012?
Provide a short and direct response. 0.69. What is the ratio of the Gross enrolment ratio (%) in Primary schools in 2009 to that in 2010?
Provide a succinct answer. 1. What is the ratio of the Gross enrolment ratio (%) in Secondary schools in 2009 to that in 2010?
Offer a terse response. 0.98. What is the ratio of the Gross enrolment ratio (%) in Tertiary schools in 2009 to that in 2010?
Provide a succinct answer. 0.93. What is the ratio of the Gross enrolment ratio (%) of Pre-primary schools in 2009 to that in 2011?
Keep it short and to the point. 1.01. What is the ratio of the Gross enrolment ratio (%) in Primary schools in 2009 to that in 2011?
Make the answer very short. 1.01. What is the ratio of the Gross enrolment ratio (%) of Secondary schools in 2009 to that in 2011?
Offer a terse response. 0.95. What is the ratio of the Gross enrolment ratio (%) of Tertiary schools in 2009 to that in 2011?
Your answer should be compact. 0.86. What is the ratio of the Gross enrolment ratio (%) of Primary schools in 2009 to that in 2012?
Your response must be concise. 1.03. What is the ratio of the Gross enrolment ratio (%) of Secondary schools in 2009 to that in 2012?
Provide a succinct answer. 0.94. What is the ratio of the Gross enrolment ratio (%) of Tertiary schools in 2009 to that in 2012?
Give a very brief answer. 0.75. What is the ratio of the Gross enrolment ratio (%) in Pre-primary schools in 2010 to that in 2011?
Your answer should be very brief. 1.01. What is the ratio of the Gross enrolment ratio (%) of Primary schools in 2010 to that in 2011?
Your answer should be compact. 1.02. What is the ratio of the Gross enrolment ratio (%) in Secondary schools in 2010 to that in 2011?
Make the answer very short. 0.97. What is the ratio of the Gross enrolment ratio (%) in Tertiary schools in 2010 to that in 2011?
Your response must be concise. 0.92. What is the ratio of the Gross enrolment ratio (%) of Primary schools in 2010 to that in 2012?
Provide a short and direct response. 1.03. What is the ratio of the Gross enrolment ratio (%) in Secondary schools in 2010 to that in 2012?
Your answer should be very brief. 0.96. What is the ratio of the Gross enrolment ratio (%) of Tertiary schools in 2010 to that in 2012?
Offer a very short reply. 0.81. What is the ratio of the Gross enrolment ratio (%) of Pre-primary schools in 2011 to that in 2012?
Your answer should be very brief. 0.99. What is the ratio of the Gross enrolment ratio (%) in Primary schools in 2011 to that in 2012?
Your answer should be compact. 1.01. What is the ratio of the Gross enrolment ratio (%) in Secondary schools in 2011 to that in 2012?
Make the answer very short. 0.99. What is the ratio of the Gross enrolment ratio (%) of Tertiary schools in 2011 to that in 2012?
Give a very brief answer. 0.87. What is the difference between the highest and the second highest Gross enrolment ratio (%) in Pre-primary schools?
Provide a succinct answer. 0.29. What is the difference between the highest and the second highest Gross enrolment ratio (%) of Primary schools?
Your answer should be compact. 0.41. What is the difference between the highest and the second highest Gross enrolment ratio (%) in Secondary schools?
Provide a succinct answer. 0.56. What is the difference between the highest and the second highest Gross enrolment ratio (%) in Tertiary schools?
Offer a very short reply. 5.84. What is the difference between the highest and the lowest Gross enrolment ratio (%) of Pre-primary schools?
Your answer should be compact. 4.03. What is the difference between the highest and the lowest Gross enrolment ratio (%) in Primary schools?
Your answer should be compact. 3.24. What is the difference between the highest and the lowest Gross enrolment ratio (%) of Secondary schools?
Provide a succinct answer. 8.21. What is the difference between the highest and the lowest Gross enrolment ratio (%) of Tertiary schools?
Your answer should be very brief. 18.26. 